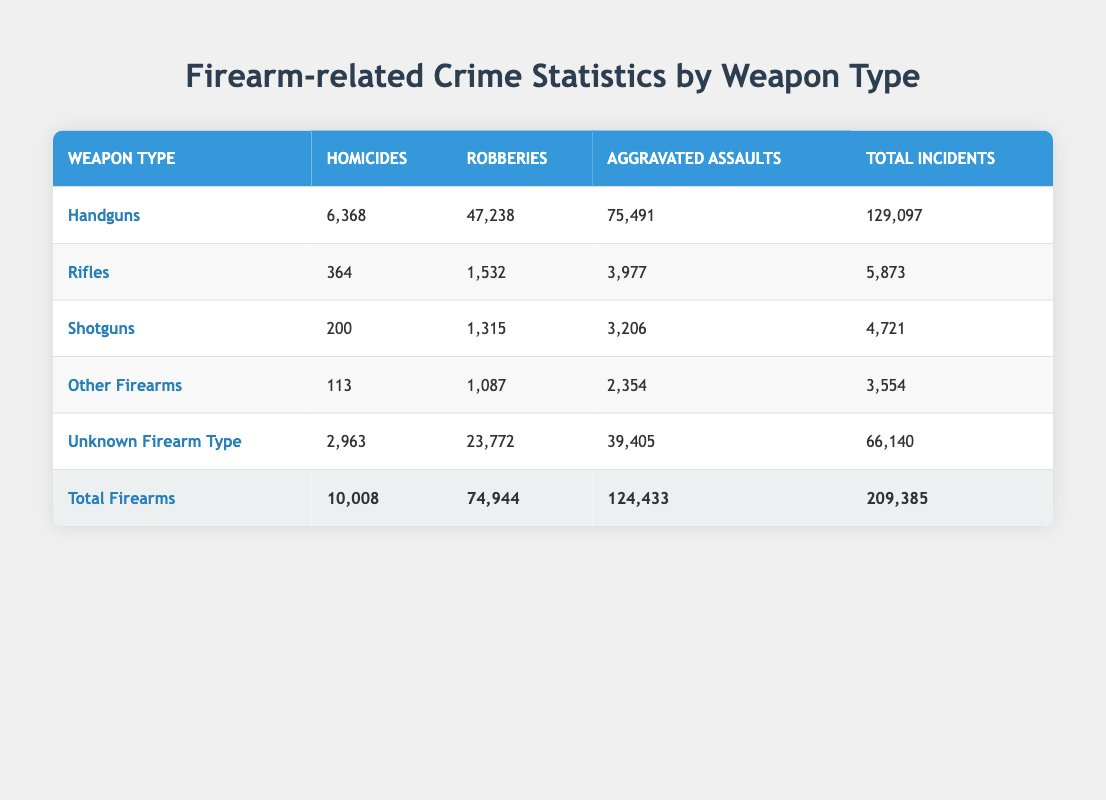What is the total number of homicides committed with handguns? According to the table, the row for handguns shows that there were 6,368 homicides.
Answer: 6,368 How many total incidents were reported for rifles? The table indicates that there were 5,873 total incidents involving rifles.
Answer: 5,873 What is the difference in the number of aggravated assaults between handguns and shotguns? Handguns had 75,491 aggravated assaults, and shotguns had 3,206. The difference is calculated as 75,491 - 3,206 = 72,285.
Answer: 72,285 Is the number of robberies involving unknown firearms greater than those involving shotguns? The table shows 23,772 robberies involving unknown firearms and 1,315 involving shotguns. Since 23,772 is greater than 1,315, the answer is yes.
Answer: Yes What is the total number of homicides across all weapon types? To find this, we sum the homicides across all weapon types: 6,368 (Handguns) + 364 (Rifles) + 200 (Shotguns) + 113 (Other Firearms) + 2,963 (Unknown Firearm Type) = 10,008.
Answer: 10,008 How many more aggravated assaults involve handguns than other firearms? Handguns show 75,491 aggravated assaults and other firearms show 2,354. The difference is 75,491 - 2,354 = 73,137.
Answer: 73,137 Are shotguns involved in more robberies or aggravated assaults? Shotguns had 1,315 robberies and 3,206 aggravated assaults. Since 3,206 is greater than 1,315, they are involved in more aggravated assaults.
Answer: Aggravated Assaults What percentage of total incidents involved handguns? Handguns account for 129,097 total incidents and the overall total for all firearms is 209,385. The percentage is calculated as (129,097 / 209,385) * 100 = 61.7%.
Answer: 61.7% What is the average number of homicides per weapon type? There are five weapon types listed in the table. The total number of homicides is 10,008. Thus, the average is calculated as 10,008 / 5 = 2,001.6.
Answer: 2,001.6 